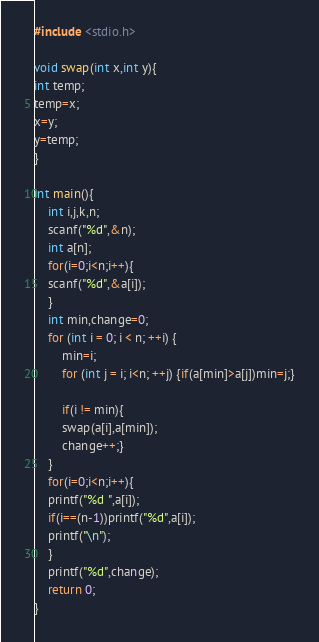<code> <loc_0><loc_0><loc_500><loc_500><_C_>#include <stdio.h>

void swap(int x,int y){
int temp;
temp=x;
x=y;
y=temp;
}

int main(){
    int i,j,k,n;
    scanf("%d",&n);
    int a[n];
    for(i=0;i<n;i++){
    scanf("%d",&a[i]);
    }
    int min,change=0;
    for (int i = 0; i < n; ++i) {
        min=i;
        for (int j = i; i<n; ++j) {if(a[min]>a[j])min=j;}

        if(i != min){
        swap(a[i],a[min]);
        change++;}
    }
    for(i=0;i<n;i++){
    printf("%d ",a[i]);
    if(i==(n-1))printf("%d",a[i]);
    printf("\n");
    }
    printf("%d",change);
    return 0;
}
</code> 